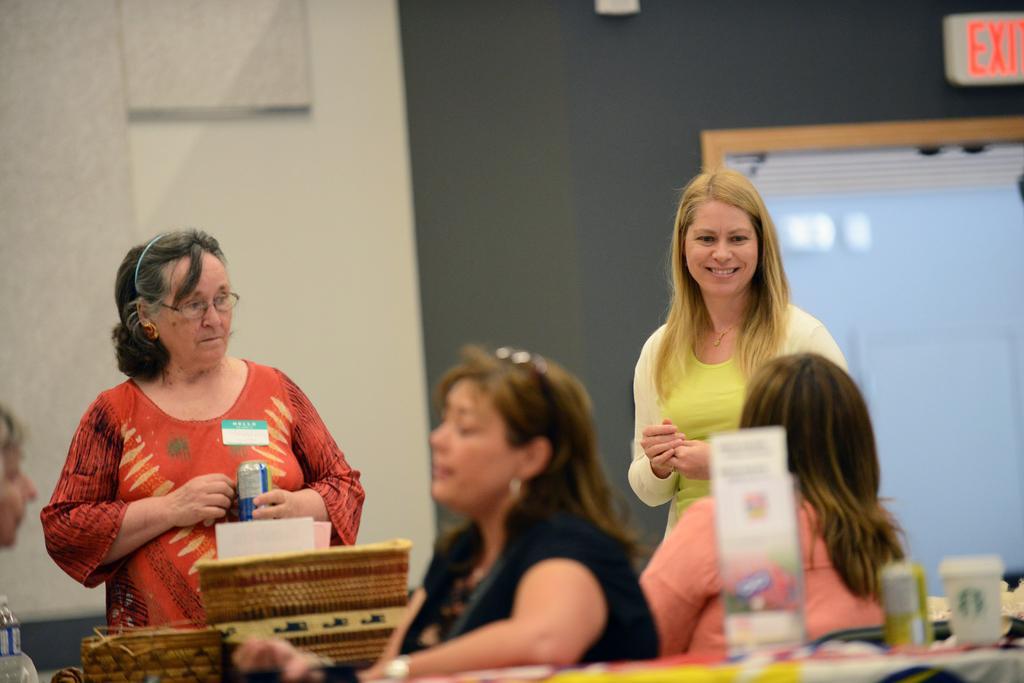How would you summarize this image in a sentence or two? In the center of the image there are ladies. In the background of the image there is wall. There is a glass window. At the bottom of the image there is table there are objects on it. 